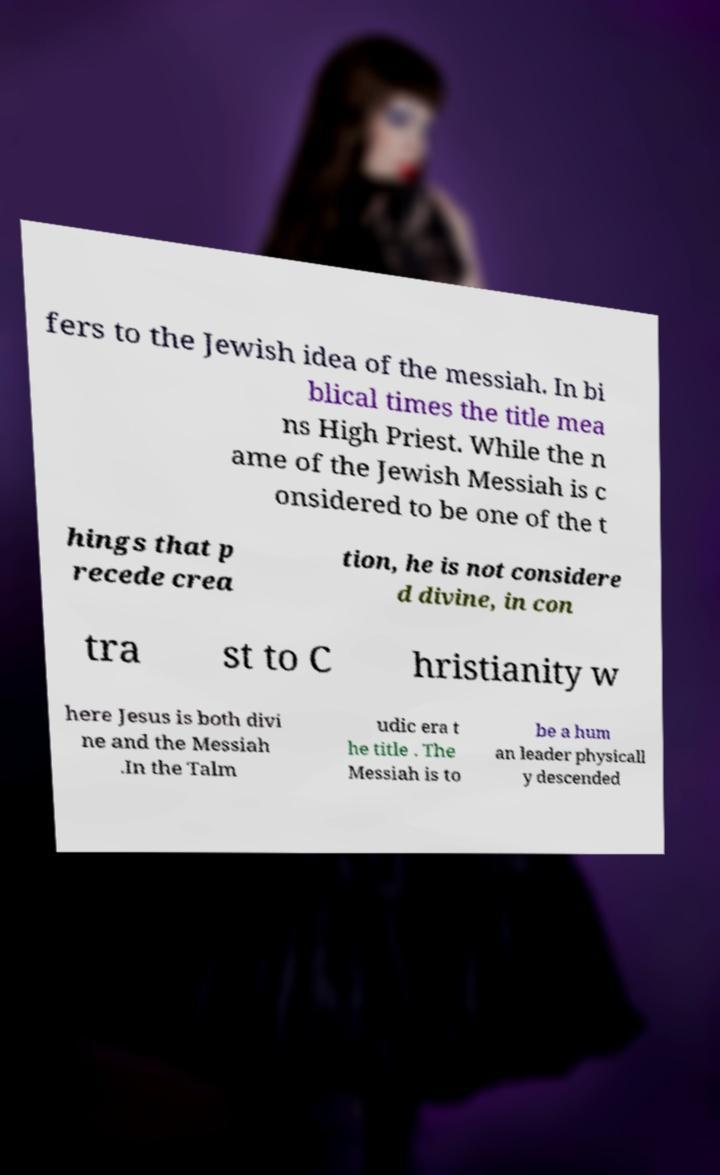I need the written content from this picture converted into text. Can you do that? fers to the Jewish idea of the messiah. In bi blical times the title mea ns High Priest. While the n ame of the Jewish Messiah is c onsidered to be one of the t hings that p recede crea tion, he is not considere d divine, in con tra st to C hristianity w here Jesus is both divi ne and the Messiah .In the Talm udic era t he title . The Messiah is to be a hum an leader physicall y descended 